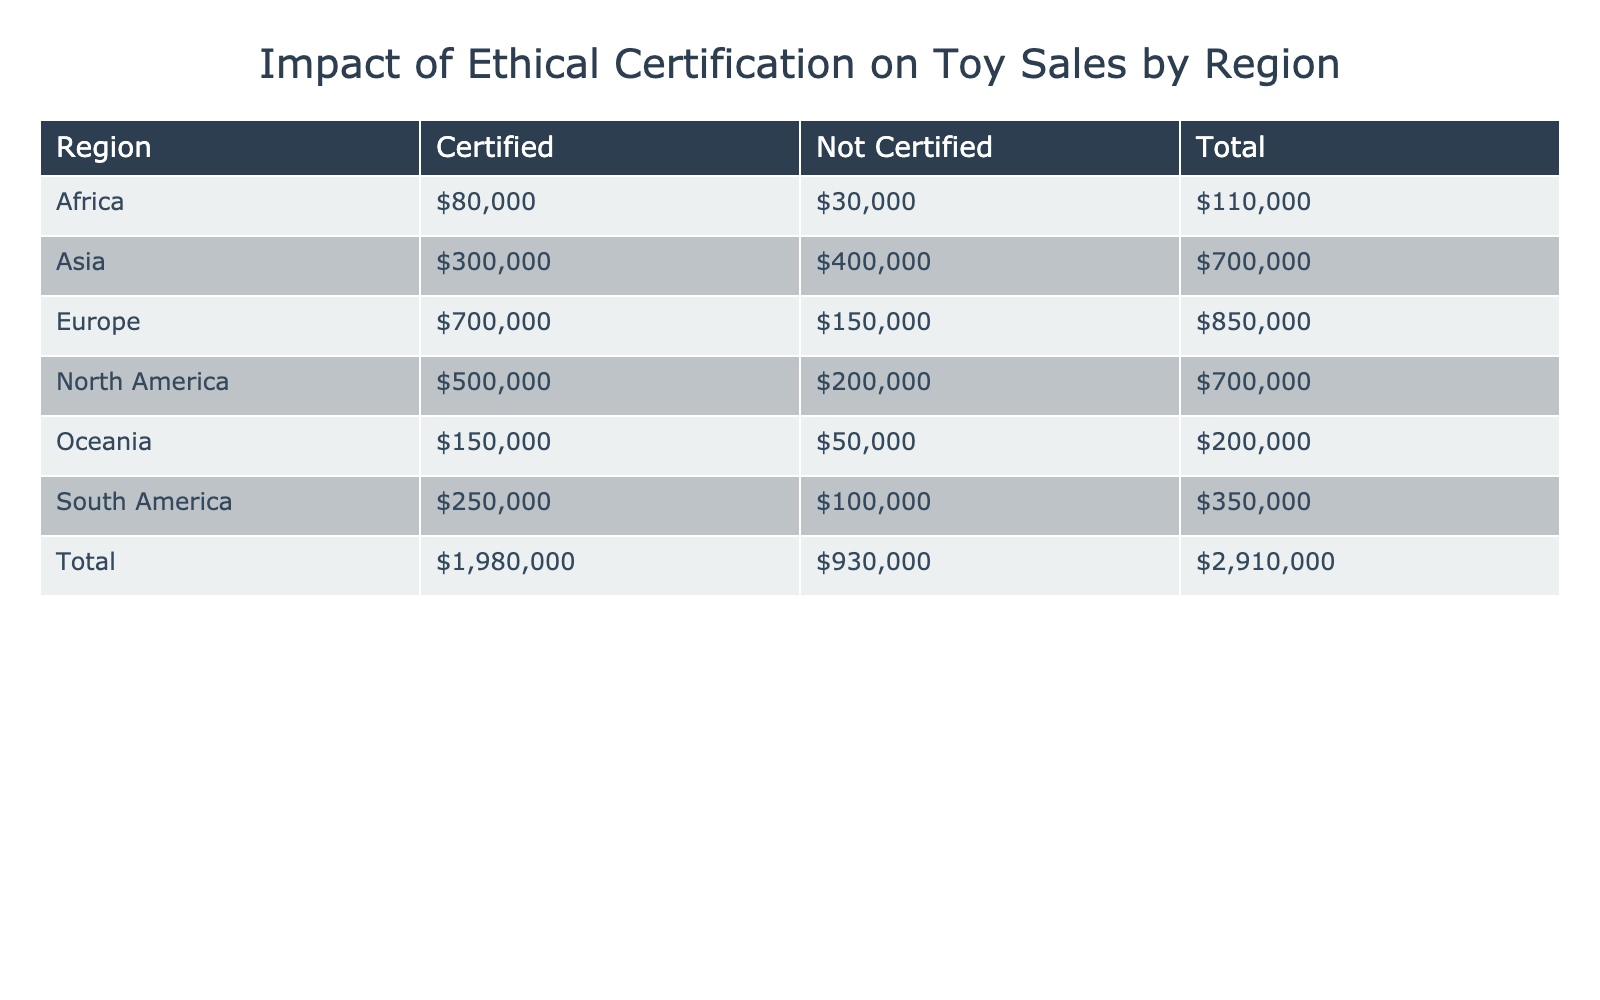What is the total sales for Certified toy products in North America? From the table, the sales for Certified toy products in North America is given as $500,000. We do not need to combine or filter any additional information.
Answer: $500,000 Which region has the highest sales for Not Certified toy products? Upon reviewing the data, Europe has the highest sales for Not Certified toy products, totaling $150,000.
Answer: Europe What is the combined total sales for Certified toy products across all regions? Adding the Certified sales from all regions gives us: North America ($500,000) + Europe ($700,000) + Asia ($300,000) + South America ($250,000) + Oceania ($150,000) + Africa ($80,000) = $1,980,000.
Answer: $1,980,000 Is the sales figure for Not Certified toy products in South America greater than that of Oceania? The table indicates that South America has sales of $100,000 for Not Certified products, while Oceania has $50,000. Since 100,000 is greater than 50,000, the statement is true.
Answer: Yes What is the difference in total sales between Certified and Not Certified toy products in Asia? For Asia, the sales figures are: Certified - $300,000 and Not Certified - $400,000. The difference is $400,000 - $300,000 = $100,000.
Answer: $100,000 Which has higher sales, the total for Europe or the total for North America? For Europe, the total sales (Certified + Not Certified) is $700,000 + $150,000 = $850,000. For North America, it's $500,000 + $200,000 = $700,000. Since $850,000 is greater than $700,000, Europe has higher sales.
Answer: Europe What is the average sales value for Not Certified products across all regions? The sales values for Not Certified products are: $200,000 (North America), $150,000 (Europe), $400,000 (Asia), $100,000 (South America), $50,000 (Oceania), and $30,000 (Africa). Adding these gives us $200,000 + $150,000 + $400,000 + $100,000 + $50,000 + $30,000 = $930,000. There are 6 regions, so averaging gives us $930,000 / 6 = $155,000.
Answer: $155,000 Is it true that Africa generated more sales from Certified products compared to Not Certified products? Africa's sales figures show $80,000 for Certified and $30,000 for Not Certified. Since $80,000 is greater than $30,000, the statement is true.
Answer: Yes What is the total sales for Not Certified products across all regions combined? Adding the Not Certified sales values: North America ($200,000) + Europe ($150,000) + Asia ($400,000) + South America ($100,000) + Oceania ($50,000) + Africa ($30,000) gives us $200,000 + $150,000 + $400,000 + $100,000 + $50,000 + $30,000 = $930,000.
Answer: $930,000 